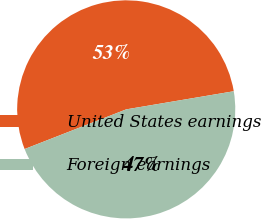Convert chart to OTSL. <chart><loc_0><loc_0><loc_500><loc_500><pie_chart><fcel>United States earnings<fcel>Foreign earnings<nl><fcel>53.27%<fcel>46.73%<nl></chart> 